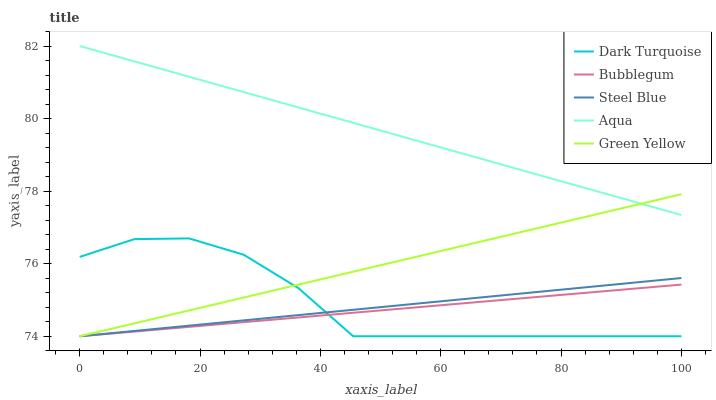Does Bubblegum have the minimum area under the curve?
Answer yes or no. Yes. Does Aqua have the maximum area under the curve?
Answer yes or no. Yes. Does Green Yellow have the minimum area under the curve?
Answer yes or no. No. Does Green Yellow have the maximum area under the curve?
Answer yes or no. No. Is Bubblegum the smoothest?
Answer yes or no. Yes. Is Dark Turquoise the roughest?
Answer yes or no. Yes. Is Green Yellow the smoothest?
Answer yes or no. No. Is Green Yellow the roughest?
Answer yes or no. No. Does Dark Turquoise have the lowest value?
Answer yes or no. Yes. Does Aqua have the lowest value?
Answer yes or no. No. Does Aqua have the highest value?
Answer yes or no. Yes. Does Green Yellow have the highest value?
Answer yes or no. No. Is Bubblegum less than Aqua?
Answer yes or no. Yes. Is Aqua greater than Dark Turquoise?
Answer yes or no. Yes. Does Bubblegum intersect Dark Turquoise?
Answer yes or no. Yes. Is Bubblegum less than Dark Turquoise?
Answer yes or no. No. Is Bubblegum greater than Dark Turquoise?
Answer yes or no. No. Does Bubblegum intersect Aqua?
Answer yes or no. No. 